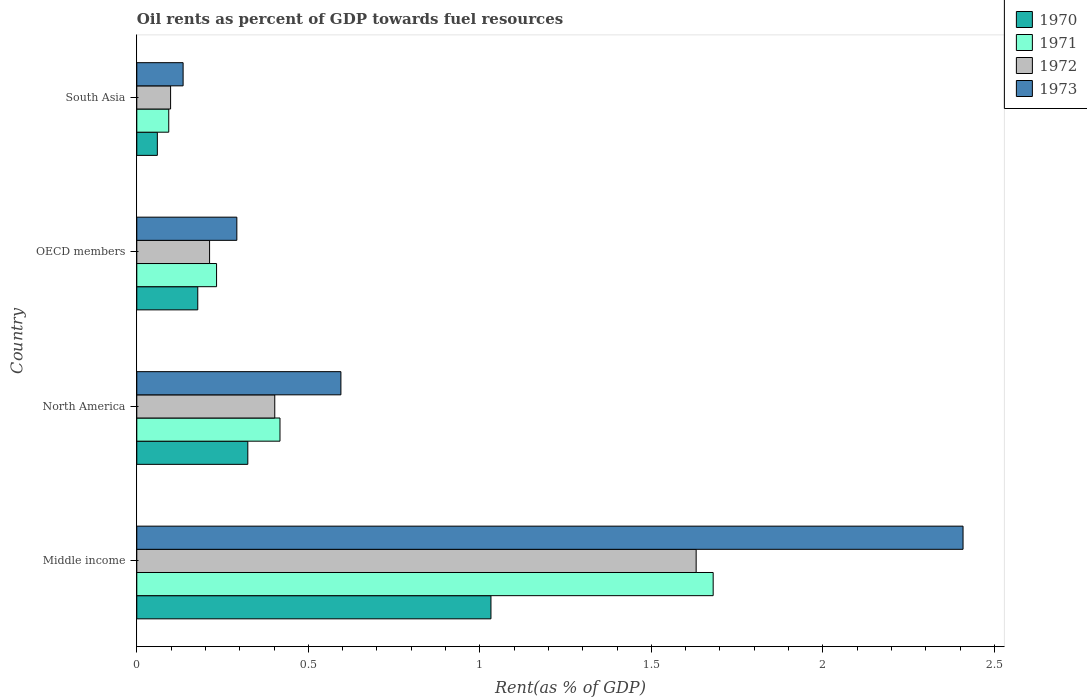Are the number of bars on each tick of the Y-axis equal?
Offer a very short reply. Yes. How many bars are there on the 2nd tick from the top?
Provide a short and direct response. 4. How many bars are there on the 4th tick from the bottom?
Make the answer very short. 4. What is the label of the 2nd group of bars from the top?
Keep it short and to the point. OECD members. In how many cases, is the number of bars for a given country not equal to the number of legend labels?
Give a very brief answer. 0. What is the oil rent in 1971 in Middle income?
Your answer should be very brief. 1.68. Across all countries, what is the maximum oil rent in 1970?
Your answer should be compact. 1.03. Across all countries, what is the minimum oil rent in 1971?
Keep it short and to the point. 0.09. In which country was the oil rent in 1971 maximum?
Your answer should be very brief. Middle income. In which country was the oil rent in 1971 minimum?
Provide a short and direct response. South Asia. What is the total oil rent in 1972 in the graph?
Keep it short and to the point. 2.34. What is the difference between the oil rent in 1970 in North America and that in South Asia?
Offer a terse response. 0.26. What is the difference between the oil rent in 1970 in Middle income and the oil rent in 1971 in North America?
Your response must be concise. 0.62. What is the average oil rent in 1973 per country?
Ensure brevity in your answer.  0.86. What is the difference between the oil rent in 1970 and oil rent in 1973 in OECD members?
Make the answer very short. -0.11. In how many countries, is the oil rent in 1972 greater than 2 %?
Make the answer very short. 0. What is the ratio of the oil rent in 1970 in Middle income to that in North America?
Make the answer very short. 3.19. What is the difference between the highest and the second highest oil rent in 1973?
Give a very brief answer. 1.81. What is the difference between the highest and the lowest oil rent in 1973?
Your answer should be very brief. 2.27. Is the sum of the oil rent in 1971 in North America and OECD members greater than the maximum oil rent in 1970 across all countries?
Give a very brief answer. No. What does the 4th bar from the top in Middle income represents?
Provide a short and direct response. 1970. What does the 1st bar from the bottom in OECD members represents?
Offer a terse response. 1970. How many bars are there?
Make the answer very short. 16. How many countries are there in the graph?
Make the answer very short. 4. What is the difference between two consecutive major ticks on the X-axis?
Offer a terse response. 0.5. Does the graph contain any zero values?
Offer a terse response. No. How many legend labels are there?
Ensure brevity in your answer.  4. How are the legend labels stacked?
Provide a succinct answer. Vertical. What is the title of the graph?
Ensure brevity in your answer.  Oil rents as percent of GDP towards fuel resources. What is the label or title of the X-axis?
Your answer should be compact. Rent(as % of GDP). What is the label or title of the Y-axis?
Keep it short and to the point. Country. What is the Rent(as % of GDP) of 1970 in Middle income?
Offer a very short reply. 1.03. What is the Rent(as % of GDP) of 1971 in Middle income?
Provide a succinct answer. 1.68. What is the Rent(as % of GDP) in 1972 in Middle income?
Make the answer very short. 1.63. What is the Rent(as % of GDP) of 1973 in Middle income?
Your answer should be compact. 2.41. What is the Rent(as % of GDP) in 1970 in North America?
Your answer should be compact. 0.32. What is the Rent(as % of GDP) in 1971 in North America?
Ensure brevity in your answer.  0.42. What is the Rent(as % of GDP) in 1972 in North America?
Your answer should be very brief. 0.4. What is the Rent(as % of GDP) of 1973 in North America?
Ensure brevity in your answer.  0.6. What is the Rent(as % of GDP) in 1970 in OECD members?
Offer a terse response. 0.18. What is the Rent(as % of GDP) in 1971 in OECD members?
Provide a short and direct response. 0.23. What is the Rent(as % of GDP) of 1972 in OECD members?
Offer a terse response. 0.21. What is the Rent(as % of GDP) of 1973 in OECD members?
Your answer should be very brief. 0.29. What is the Rent(as % of GDP) of 1970 in South Asia?
Keep it short and to the point. 0.06. What is the Rent(as % of GDP) of 1971 in South Asia?
Ensure brevity in your answer.  0.09. What is the Rent(as % of GDP) of 1972 in South Asia?
Keep it short and to the point. 0.1. What is the Rent(as % of GDP) in 1973 in South Asia?
Keep it short and to the point. 0.14. Across all countries, what is the maximum Rent(as % of GDP) in 1970?
Make the answer very short. 1.03. Across all countries, what is the maximum Rent(as % of GDP) of 1971?
Ensure brevity in your answer.  1.68. Across all countries, what is the maximum Rent(as % of GDP) in 1972?
Your answer should be compact. 1.63. Across all countries, what is the maximum Rent(as % of GDP) of 1973?
Make the answer very short. 2.41. Across all countries, what is the minimum Rent(as % of GDP) of 1970?
Provide a succinct answer. 0.06. Across all countries, what is the minimum Rent(as % of GDP) of 1971?
Provide a short and direct response. 0.09. Across all countries, what is the minimum Rent(as % of GDP) in 1972?
Your answer should be very brief. 0.1. Across all countries, what is the minimum Rent(as % of GDP) in 1973?
Offer a terse response. 0.14. What is the total Rent(as % of GDP) in 1970 in the graph?
Make the answer very short. 1.59. What is the total Rent(as % of GDP) in 1971 in the graph?
Your response must be concise. 2.42. What is the total Rent(as % of GDP) in 1972 in the graph?
Make the answer very short. 2.34. What is the total Rent(as % of GDP) of 1973 in the graph?
Offer a terse response. 3.43. What is the difference between the Rent(as % of GDP) of 1970 in Middle income and that in North America?
Keep it short and to the point. 0.71. What is the difference between the Rent(as % of GDP) in 1971 in Middle income and that in North America?
Your answer should be compact. 1.26. What is the difference between the Rent(as % of GDP) in 1972 in Middle income and that in North America?
Ensure brevity in your answer.  1.23. What is the difference between the Rent(as % of GDP) in 1973 in Middle income and that in North America?
Offer a very short reply. 1.81. What is the difference between the Rent(as % of GDP) in 1970 in Middle income and that in OECD members?
Your response must be concise. 0.85. What is the difference between the Rent(as % of GDP) of 1971 in Middle income and that in OECD members?
Provide a succinct answer. 1.45. What is the difference between the Rent(as % of GDP) of 1972 in Middle income and that in OECD members?
Give a very brief answer. 1.42. What is the difference between the Rent(as % of GDP) of 1973 in Middle income and that in OECD members?
Give a very brief answer. 2.12. What is the difference between the Rent(as % of GDP) of 1970 in Middle income and that in South Asia?
Your response must be concise. 0.97. What is the difference between the Rent(as % of GDP) of 1971 in Middle income and that in South Asia?
Your answer should be compact. 1.59. What is the difference between the Rent(as % of GDP) in 1972 in Middle income and that in South Asia?
Make the answer very short. 1.53. What is the difference between the Rent(as % of GDP) in 1973 in Middle income and that in South Asia?
Keep it short and to the point. 2.27. What is the difference between the Rent(as % of GDP) in 1970 in North America and that in OECD members?
Keep it short and to the point. 0.15. What is the difference between the Rent(as % of GDP) of 1971 in North America and that in OECD members?
Ensure brevity in your answer.  0.18. What is the difference between the Rent(as % of GDP) in 1972 in North America and that in OECD members?
Provide a succinct answer. 0.19. What is the difference between the Rent(as % of GDP) in 1973 in North America and that in OECD members?
Your answer should be very brief. 0.3. What is the difference between the Rent(as % of GDP) of 1970 in North America and that in South Asia?
Keep it short and to the point. 0.26. What is the difference between the Rent(as % of GDP) of 1971 in North America and that in South Asia?
Offer a terse response. 0.32. What is the difference between the Rent(as % of GDP) in 1972 in North America and that in South Asia?
Offer a very short reply. 0.3. What is the difference between the Rent(as % of GDP) of 1973 in North America and that in South Asia?
Your response must be concise. 0.46. What is the difference between the Rent(as % of GDP) in 1970 in OECD members and that in South Asia?
Provide a short and direct response. 0.12. What is the difference between the Rent(as % of GDP) of 1971 in OECD members and that in South Asia?
Your answer should be very brief. 0.14. What is the difference between the Rent(as % of GDP) of 1972 in OECD members and that in South Asia?
Your response must be concise. 0.11. What is the difference between the Rent(as % of GDP) of 1973 in OECD members and that in South Asia?
Ensure brevity in your answer.  0.16. What is the difference between the Rent(as % of GDP) in 1970 in Middle income and the Rent(as % of GDP) in 1971 in North America?
Make the answer very short. 0.61. What is the difference between the Rent(as % of GDP) in 1970 in Middle income and the Rent(as % of GDP) in 1972 in North America?
Make the answer very short. 0.63. What is the difference between the Rent(as % of GDP) in 1970 in Middle income and the Rent(as % of GDP) in 1973 in North America?
Offer a terse response. 0.44. What is the difference between the Rent(as % of GDP) in 1971 in Middle income and the Rent(as % of GDP) in 1972 in North America?
Offer a very short reply. 1.28. What is the difference between the Rent(as % of GDP) in 1971 in Middle income and the Rent(as % of GDP) in 1973 in North America?
Give a very brief answer. 1.09. What is the difference between the Rent(as % of GDP) in 1972 in Middle income and the Rent(as % of GDP) in 1973 in North America?
Make the answer very short. 1.04. What is the difference between the Rent(as % of GDP) of 1970 in Middle income and the Rent(as % of GDP) of 1971 in OECD members?
Your answer should be compact. 0.8. What is the difference between the Rent(as % of GDP) in 1970 in Middle income and the Rent(as % of GDP) in 1972 in OECD members?
Your answer should be very brief. 0.82. What is the difference between the Rent(as % of GDP) of 1970 in Middle income and the Rent(as % of GDP) of 1973 in OECD members?
Your answer should be very brief. 0.74. What is the difference between the Rent(as % of GDP) of 1971 in Middle income and the Rent(as % of GDP) of 1972 in OECD members?
Offer a very short reply. 1.47. What is the difference between the Rent(as % of GDP) in 1971 in Middle income and the Rent(as % of GDP) in 1973 in OECD members?
Provide a succinct answer. 1.39. What is the difference between the Rent(as % of GDP) of 1972 in Middle income and the Rent(as % of GDP) of 1973 in OECD members?
Your answer should be very brief. 1.34. What is the difference between the Rent(as % of GDP) in 1970 in Middle income and the Rent(as % of GDP) in 1971 in South Asia?
Give a very brief answer. 0.94. What is the difference between the Rent(as % of GDP) in 1970 in Middle income and the Rent(as % of GDP) in 1972 in South Asia?
Make the answer very short. 0.93. What is the difference between the Rent(as % of GDP) of 1970 in Middle income and the Rent(as % of GDP) of 1973 in South Asia?
Your answer should be compact. 0.9. What is the difference between the Rent(as % of GDP) of 1971 in Middle income and the Rent(as % of GDP) of 1972 in South Asia?
Provide a short and direct response. 1.58. What is the difference between the Rent(as % of GDP) in 1971 in Middle income and the Rent(as % of GDP) in 1973 in South Asia?
Ensure brevity in your answer.  1.55. What is the difference between the Rent(as % of GDP) in 1972 in Middle income and the Rent(as % of GDP) in 1973 in South Asia?
Offer a terse response. 1.5. What is the difference between the Rent(as % of GDP) in 1970 in North America and the Rent(as % of GDP) in 1971 in OECD members?
Your answer should be compact. 0.09. What is the difference between the Rent(as % of GDP) in 1970 in North America and the Rent(as % of GDP) in 1972 in OECD members?
Offer a very short reply. 0.11. What is the difference between the Rent(as % of GDP) of 1970 in North America and the Rent(as % of GDP) of 1973 in OECD members?
Keep it short and to the point. 0.03. What is the difference between the Rent(as % of GDP) in 1971 in North America and the Rent(as % of GDP) in 1972 in OECD members?
Offer a very short reply. 0.21. What is the difference between the Rent(as % of GDP) of 1971 in North America and the Rent(as % of GDP) of 1973 in OECD members?
Provide a short and direct response. 0.13. What is the difference between the Rent(as % of GDP) in 1972 in North America and the Rent(as % of GDP) in 1973 in OECD members?
Keep it short and to the point. 0.11. What is the difference between the Rent(as % of GDP) of 1970 in North America and the Rent(as % of GDP) of 1971 in South Asia?
Offer a terse response. 0.23. What is the difference between the Rent(as % of GDP) of 1970 in North America and the Rent(as % of GDP) of 1972 in South Asia?
Offer a terse response. 0.23. What is the difference between the Rent(as % of GDP) of 1970 in North America and the Rent(as % of GDP) of 1973 in South Asia?
Keep it short and to the point. 0.19. What is the difference between the Rent(as % of GDP) in 1971 in North America and the Rent(as % of GDP) in 1972 in South Asia?
Ensure brevity in your answer.  0.32. What is the difference between the Rent(as % of GDP) of 1971 in North America and the Rent(as % of GDP) of 1973 in South Asia?
Give a very brief answer. 0.28. What is the difference between the Rent(as % of GDP) in 1972 in North America and the Rent(as % of GDP) in 1973 in South Asia?
Make the answer very short. 0.27. What is the difference between the Rent(as % of GDP) in 1970 in OECD members and the Rent(as % of GDP) in 1971 in South Asia?
Provide a succinct answer. 0.08. What is the difference between the Rent(as % of GDP) of 1970 in OECD members and the Rent(as % of GDP) of 1972 in South Asia?
Your response must be concise. 0.08. What is the difference between the Rent(as % of GDP) in 1970 in OECD members and the Rent(as % of GDP) in 1973 in South Asia?
Ensure brevity in your answer.  0.04. What is the difference between the Rent(as % of GDP) in 1971 in OECD members and the Rent(as % of GDP) in 1972 in South Asia?
Your answer should be very brief. 0.13. What is the difference between the Rent(as % of GDP) in 1971 in OECD members and the Rent(as % of GDP) in 1973 in South Asia?
Make the answer very short. 0.1. What is the difference between the Rent(as % of GDP) in 1972 in OECD members and the Rent(as % of GDP) in 1973 in South Asia?
Ensure brevity in your answer.  0.08. What is the average Rent(as % of GDP) of 1970 per country?
Your answer should be compact. 0.4. What is the average Rent(as % of GDP) in 1971 per country?
Offer a terse response. 0.61. What is the average Rent(as % of GDP) of 1972 per country?
Provide a succinct answer. 0.59. What is the average Rent(as % of GDP) in 1973 per country?
Offer a very short reply. 0.86. What is the difference between the Rent(as % of GDP) of 1970 and Rent(as % of GDP) of 1971 in Middle income?
Keep it short and to the point. -0.65. What is the difference between the Rent(as % of GDP) of 1970 and Rent(as % of GDP) of 1972 in Middle income?
Make the answer very short. -0.6. What is the difference between the Rent(as % of GDP) of 1970 and Rent(as % of GDP) of 1973 in Middle income?
Keep it short and to the point. -1.38. What is the difference between the Rent(as % of GDP) of 1971 and Rent(as % of GDP) of 1972 in Middle income?
Ensure brevity in your answer.  0.05. What is the difference between the Rent(as % of GDP) in 1971 and Rent(as % of GDP) in 1973 in Middle income?
Offer a terse response. -0.73. What is the difference between the Rent(as % of GDP) in 1972 and Rent(as % of GDP) in 1973 in Middle income?
Provide a short and direct response. -0.78. What is the difference between the Rent(as % of GDP) in 1970 and Rent(as % of GDP) in 1971 in North America?
Your answer should be compact. -0.09. What is the difference between the Rent(as % of GDP) of 1970 and Rent(as % of GDP) of 1972 in North America?
Your answer should be very brief. -0.08. What is the difference between the Rent(as % of GDP) in 1970 and Rent(as % of GDP) in 1973 in North America?
Ensure brevity in your answer.  -0.27. What is the difference between the Rent(as % of GDP) in 1971 and Rent(as % of GDP) in 1972 in North America?
Keep it short and to the point. 0.02. What is the difference between the Rent(as % of GDP) in 1971 and Rent(as % of GDP) in 1973 in North America?
Offer a terse response. -0.18. What is the difference between the Rent(as % of GDP) in 1972 and Rent(as % of GDP) in 1973 in North America?
Ensure brevity in your answer.  -0.19. What is the difference between the Rent(as % of GDP) of 1970 and Rent(as % of GDP) of 1971 in OECD members?
Provide a succinct answer. -0.05. What is the difference between the Rent(as % of GDP) in 1970 and Rent(as % of GDP) in 1972 in OECD members?
Give a very brief answer. -0.03. What is the difference between the Rent(as % of GDP) of 1970 and Rent(as % of GDP) of 1973 in OECD members?
Your response must be concise. -0.11. What is the difference between the Rent(as % of GDP) in 1971 and Rent(as % of GDP) in 1972 in OECD members?
Offer a terse response. 0.02. What is the difference between the Rent(as % of GDP) of 1971 and Rent(as % of GDP) of 1973 in OECD members?
Your answer should be very brief. -0.06. What is the difference between the Rent(as % of GDP) in 1972 and Rent(as % of GDP) in 1973 in OECD members?
Your response must be concise. -0.08. What is the difference between the Rent(as % of GDP) of 1970 and Rent(as % of GDP) of 1971 in South Asia?
Provide a succinct answer. -0.03. What is the difference between the Rent(as % of GDP) of 1970 and Rent(as % of GDP) of 1972 in South Asia?
Offer a very short reply. -0.04. What is the difference between the Rent(as % of GDP) in 1970 and Rent(as % of GDP) in 1973 in South Asia?
Your response must be concise. -0.08. What is the difference between the Rent(as % of GDP) in 1971 and Rent(as % of GDP) in 1972 in South Asia?
Provide a short and direct response. -0.01. What is the difference between the Rent(as % of GDP) of 1971 and Rent(as % of GDP) of 1973 in South Asia?
Your answer should be very brief. -0.04. What is the difference between the Rent(as % of GDP) in 1972 and Rent(as % of GDP) in 1973 in South Asia?
Offer a terse response. -0.04. What is the ratio of the Rent(as % of GDP) in 1970 in Middle income to that in North America?
Your answer should be very brief. 3.19. What is the ratio of the Rent(as % of GDP) of 1971 in Middle income to that in North America?
Ensure brevity in your answer.  4.03. What is the ratio of the Rent(as % of GDP) in 1972 in Middle income to that in North America?
Offer a terse response. 4.05. What is the ratio of the Rent(as % of GDP) in 1973 in Middle income to that in North America?
Give a very brief answer. 4.05. What is the ratio of the Rent(as % of GDP) of 1970 in Middle income to that in OECD members?
Ensure brevity in your answer.  5.81. What is the ratio of the Rent(as % of GDP) in 1971 in Middle income to that in OECD members?
Make the answer very short. 7.23. What is the ratio of the Rent(as % of GDP) of 1972 in Middle income to that in OECD members?
Keep it short and to the point. 7.68. What is the ratio of the Rent(as % of GDP) of 1973 in Middle income to that in OECD members?
Your response must be concise. 8.26. What is the ratio of the Rent(as % of GDP) of 1970 in Middle income to that in South Asia?
Provide a short and direct response. 17.23. What is the ratio of the Rent(as % of GDP) of 1971 in Middle income to that in South Asia?
Provide a succinct answer. 18.04. What is the ratio of the Rent(as % of GDP) in 1972 in Middle income to that in South Asia?
Make the answer very short. 16.55. What is the ratio of the Rent(as % of GDP) of 1973 in Middle income to that in South Asia?
Offer a very short reply. 17.84. What is the ratio of the Rent(as % of GDP) of 1970 in North America to that in OECD members?
Offer a very short reply. 1.82. What is the ratio of the Rent(as % of GDP) of 1971 in North America to that in OECD members?
Offer a very short reply. 1.8. What is the ratio of the Rent(as % of GDP) of 1972 in North America to that in OECD members?
Provide a succinct answer. 1.9. What is the ratio of the Rent(as % of GDP) in 1973 in North America to that in OECD members?
Keep it short and to the point. 2.04. What is the ratio of the Rent(as % of GDP) of 1970 in North America to that in South Asia?
Keep it short and to the point. 5.4. What is the ratio of the Rent(as % of GDP) of 1971 in North America to that in South Asia?
Your response must be concise. 4.48. What is the ratio of the Rent(as % of GDP) of 1972 in North America to that in South Asia?
Offer a very short reply. 4.08. What is the ratio of the Rent(as % of GDP) of 1973 in North America to that in South Asia?
Give a very brief answer. 4.41. What is the ratio of the Rent(as % of GDP) in 1970 in OECD members to that in South Asia?
Your answer should be very brief. 2.97. What is the ratio of the Rent(as % of GDP) of 1971 in OECD members to that in South Asia?
Your answer should be very brief. 2.5. What is the ratio of the Rent(as % of GDP) of 1972 in OECD members to that in South Asia?
Provide a succinct answer. 2.15. What is the ratio of the Rent(as % of GDP) of 1973 in OECD members to that in South Asia?
Ensure brevity in your answer.  2.16. What is the difference between the highest and the second highest Rent(as % of GDP) of 1970?
Provide a succinct answer. 0.71. What is the difference between the highest and the second highest Rent(as % of GDP) of 1971?
Your answer should be compact. 1.26. What is the difference between the highest and the second highest Rent(as % of GDP) of 1972?
Your answer should be compact. 1.23. What is the difference between the highest and the second highest Rent(as % of GDP) of 1973?
Provide a short and direct response. 1.81. What is the difference between the highest and the lowest Rent(as % of GDP) of 1970?
Offer a terse response. 0.97. What is the difference between the highest and the lowest Rent(as % of GDP) of 1971?
Provide a succinct answer. 1.59. What is the difference between the highest and the lowest Rent(as % of GDP) in 1972?
Offer a terse response. 1.53. What is the difference between the highest and the lowest Rent(as % of GDP) of 1973?
Ensure brevity in your answer.  2.27. 